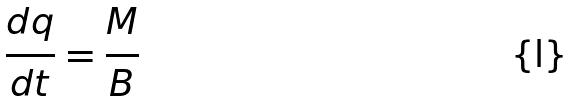<formula> <loc_0><loc_0><loc_500><loc_500>\frac { d q } { d t } = \frac { M } { B }</formula> 